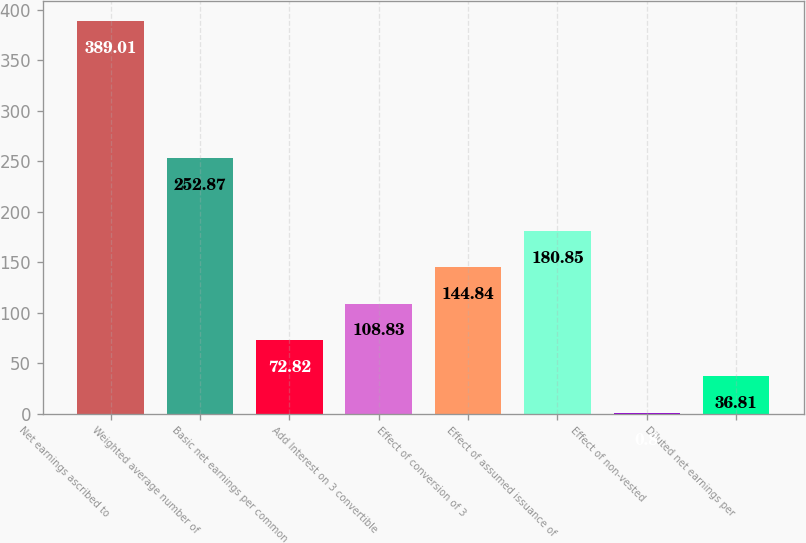Convert chart. <chart><loc_0><loc_0><loc_500><loc_500><bar_chart><fcel>Net earnings ascribed to<fcel>Weighted average number of<fcel>Basic net earnings per common<fcel>Add Interest on 3 convertible<fcel>Effect of conversion of 3<fcel>Effect of assumed issuance of<fcel>Effect of non-vested<fcel>Diluted net earnings per<nl><fcel>389.01<fcel>252.87<fcel>72.82<fcel>108.83<fcel>144.84<fcel>180.85<fcel>0.8<fcel>36.81<nl></chart> 